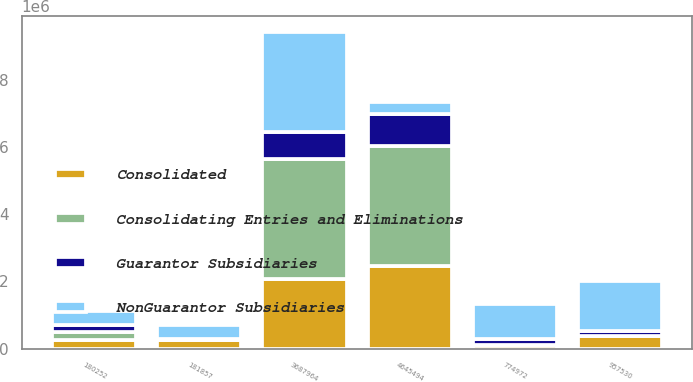Convert chart to OTSL. <chart><loc_0><loc_0><loc_500><loc_500><stacked_bar_chart><ecel><fcel>4645494<fcel>3687964<fcel>957530<fcel>774972<fcel>181857<fcel>180252<nl><fcel>Guarantor Subsidiaries<fcel>947083<fcel>791992<fcel>155091<fcel>162128<fcel>6836<fcel>218859<nl><fcel>Consolidated<fcel>2.45359e+06<fcel>2.07525e+06<fcel>378340<fcel>113508<fcel>265433<fcel>258578<nl><fcel>Consolidating Entries and Eliminations<fcel>3.57333e+06<fcel>3.5677e+06<fcel>5629<fcel>1225<fcel>6854<fcel>241369<nl><fcel>NonGuarantor Subsidiaries<fcel>378340<fcel>2.9875e+06<fcel>1.48533e+06<fcel>1.05183e+06<fcel>433600<fcel>416320<nl></chart> 